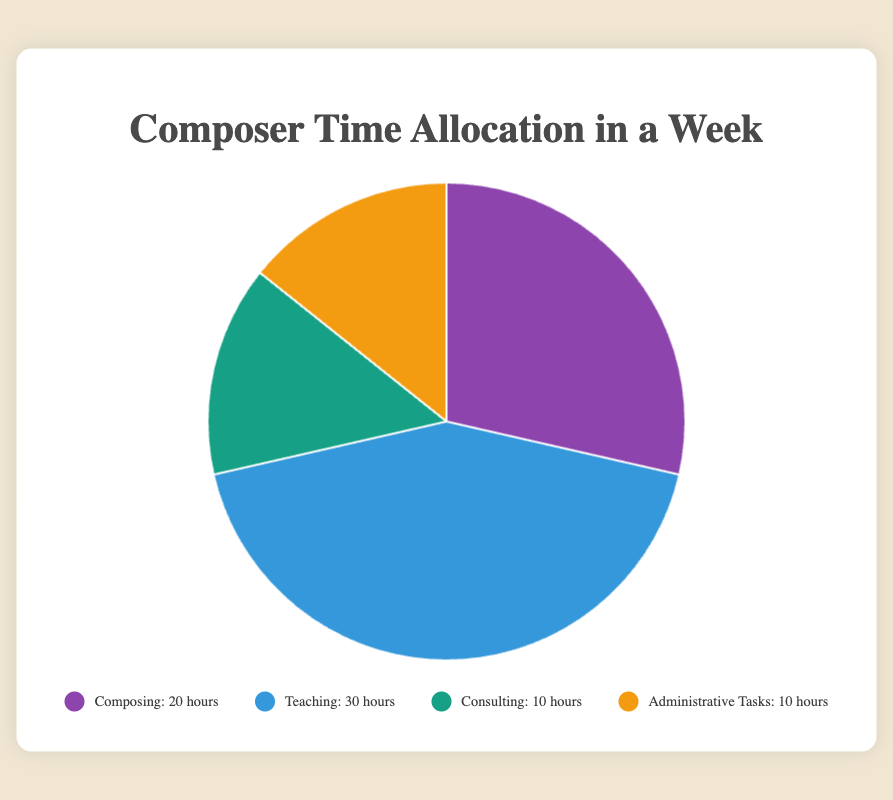What is the total time spent on non-composing activities in a week? The figure shows the time allocation for each activity. Summing the time for Teaching (30 hours), Consulting (10 hours), and Administrative Tasks (10 hours) yields the total time spent on non-composing activities: 30 + 10 + 10 = 50 hours.
Answer: 50 hours Which activity occupies the largest portion of the composer's week? By observing the segments of the pie chart, Teaching has the largest segment with 30 hours.
Answer: Teaching How much more time is spent on Teaching compared to Consulting and Administrative Tasks combined? Teaching occupies 30 hours. Consulting and Administrative Tasks each occupy 10 hours. Adding these gives 10 + 10 = 20 hours. The difference is 30 - 20 = 10 hours.
Answer: 10 hours Which two activities have the same amount of time allocated? By examining the pie chart, both Consulting and Administrative Tasks each have 10 hours allocated.
Answer: Consulting and Administrative Tasks What fraction of the week is spent on Composing? The total time allocated is 70 hours (20 + 30 + 10 + 10). The fraction for Composing is 20/70, which simplifies to 2/7.
Answer: 2/7 Is more time spent on administrative tasks or composing? By comparing the segments, Composing (20 hours) is larger than Administrative Tasks (10 hours).
Answer: Composing What percentage of the week is spent on Teaching? The total allocation is 70 hours. Teaching is 30 hours. The percentage is (30/70) * 100 = ~42.86%.
Answer: ~42.86% What is the combined time spent on Composing and Teaching? Adding the time for Composing (20 hours) and Teaching (30 hours) gives 20 + 30 = 50 hours.
Answer: 50 hours If the composer allocated 5 more hours to Consulting, which activity would it then equal in time allocation? Current Consulting is 10 hours. Adding 5 hours gives 10 + 5 = 15 hours. Comparing with other segments, it will not equal any of the current time allocations (20, 30, 10, 10).
Answer: None If the total weekly time increased to 80 hours, with the increases only in the Composing segment to maintain the same percentages, how many hours would be spent on Composing? Initially, Composing is 20/70 hours of the total time. If the total time changes to 80 hours, maintaining the same percentage, Composing would be (20/70) * 80 ≈ 22.86 hours.
Answer: ~22.86 hours 